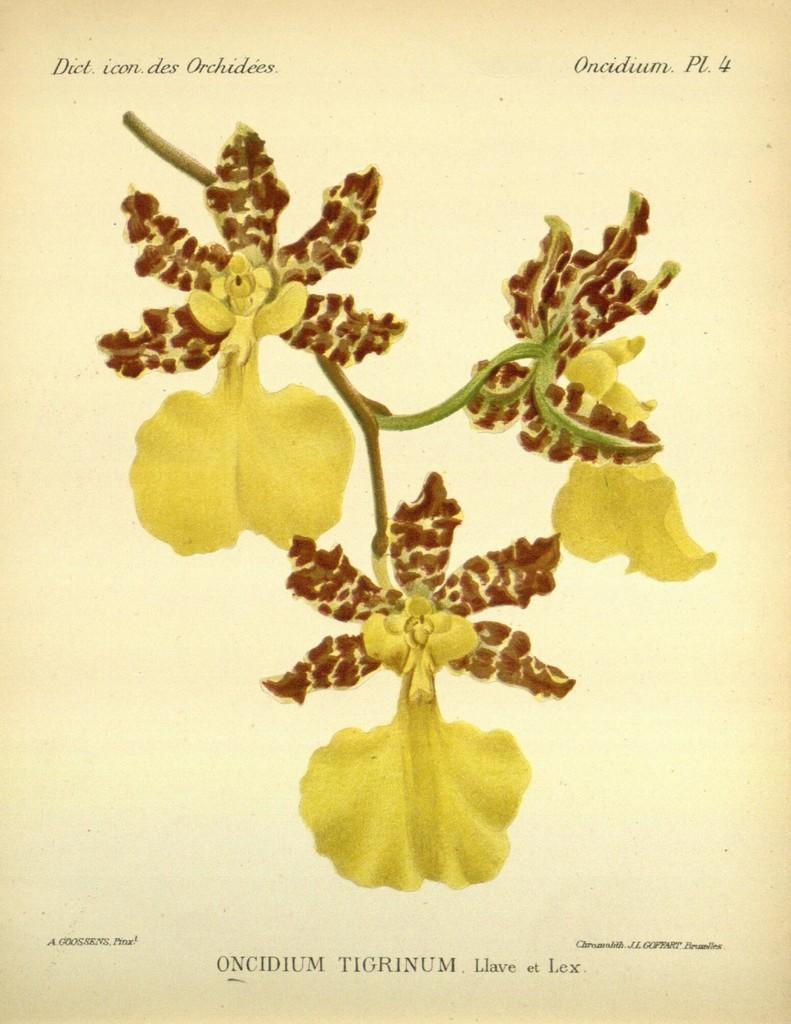<image>
Create a compact narrative representing the image presented. A poster of yellow flowers that says Oncidium Pl 4 on it. 